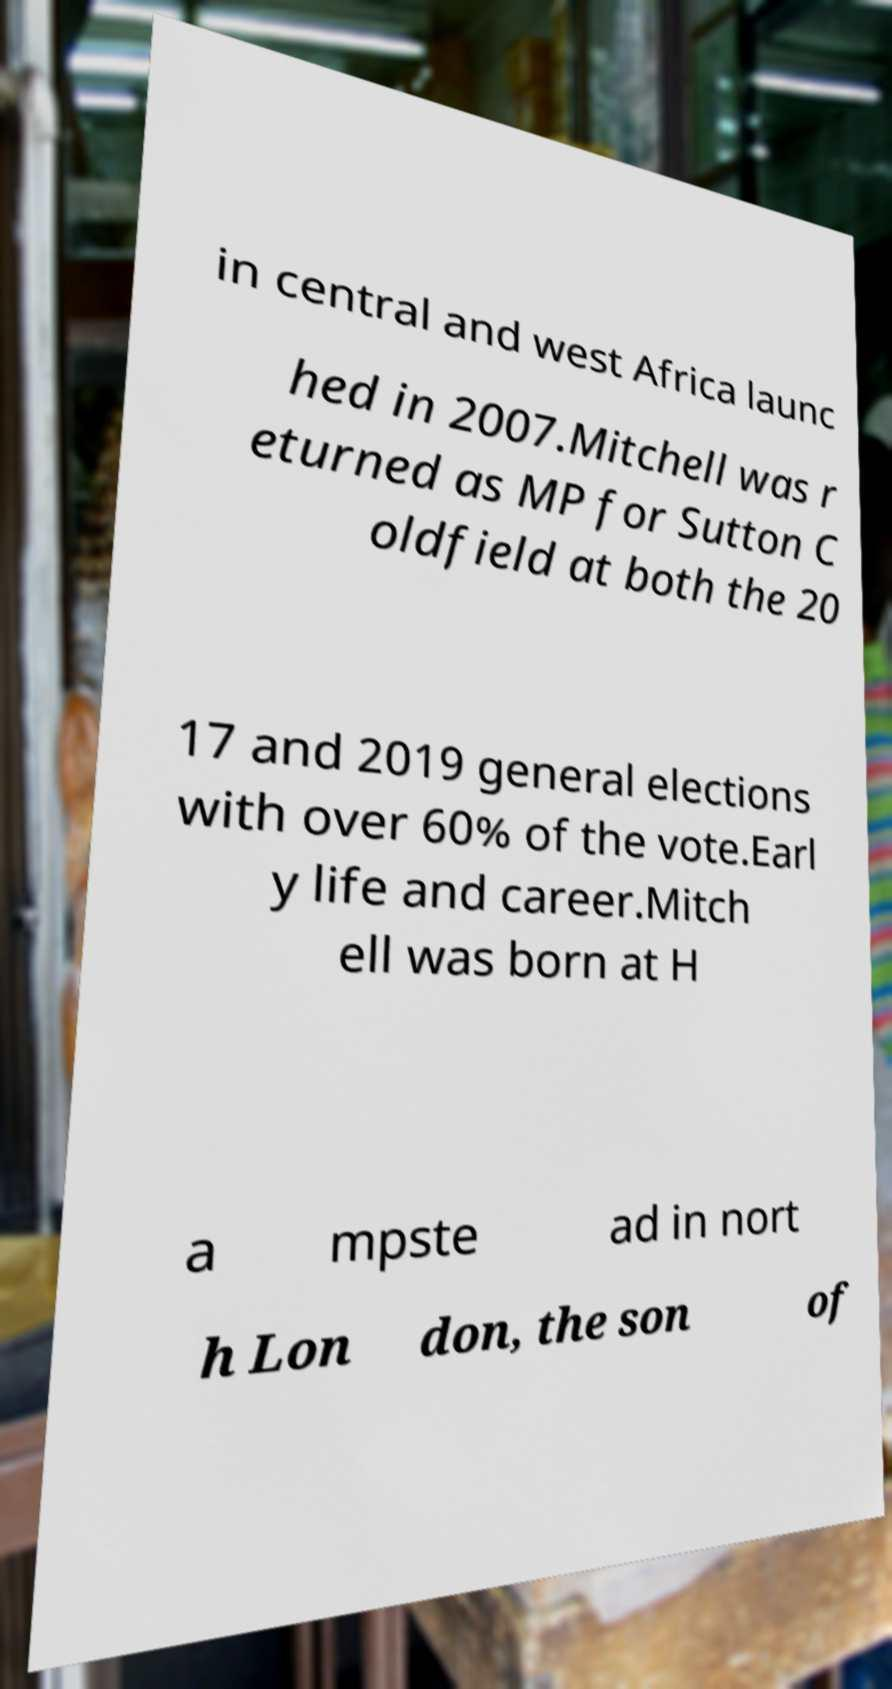Please identify and transcribe the text found in this image. in central and west Africa launc hed in 2007.Mitchell was r eturned as MP for Sutton C oldfield at both the 20 17 and 2019 general elections with over 60% of the vote.Earl y life and career.Mitch ell was born at H a mpste ad in nort h Lon don, the son of 